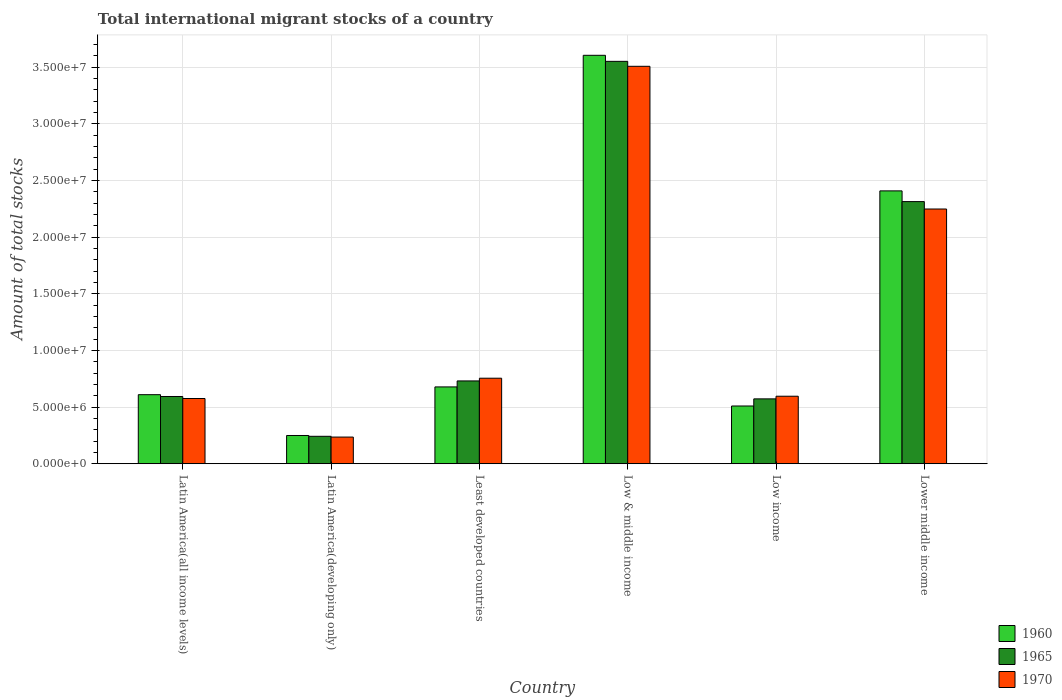How many different coloured bars are there?
Your response must be concise. 3. What is the label of the 3rd group of bars from the left?
Make the answer very short. Least developed countries. What is the amount of total stocks in in 1960 in Low & middle income?
Ensure brevity in your answer.  3.61e+07. Across all countries, what is the maximum amount of total stocks in in 1970?
Make the answer very short. 3.51e+07. Across all countries, what is the minimum amount of total stocks in in 1965?
Give a very brief answer. 2.42e+06. In which country was the amount of total stocks in in 1965 minimum?
Give a very brief answer. Latin America(developing only). What is the total amount of total stocks in in 1970 in the graph?
Your answer should be very brief. 7.92e+07. What is the difference between the amount of total stocks in in 1965 in Latin America(all income levels) and that in Latin America(developing only)?
Make the answer very short. 3.51e+06. What is the difference between the amount of total stocks in in 1970 in Low income and the amount of total stocks in in 1965 in Least developed countries?
Give a very brief answer. -1.35e+06. What is the average amount of total stocks in in 1970 per country?
Your answer should be compact. 1.32e+07. What is the difference between the amount of total stocks in of/in 1965 and amount of total stocks in of/in 1960 in Low income?
Provide a succinct answer. 6.30e+05. What is the ratio of the amount of total stocks in in 1960 in Latin America(all income levels) to that in Lower middle income?
Offer a very short reply. 0.25. Is the amount of total stocks in in 1960 in Low & middle income less than that in Lower middle income?
Offer a terse response. No. What is the difference between the highest and the second highest amount of total stocks in in 1970?
Give a very brief answer. 1.49e+07. What is the difference between the highest and the lowest amount of total stocks in in 1965?
Make the answer very short. 3.31e+07. Is the sum of the amount of total stocks in in 1965 in Low income and Lower middle income greater than the maximum amount of total stocks in in 1970 across all countries?
Ensure brevity in your answer.  No. What does the 1st bar from the left in Low income represents?
Provide a short and direct response. 1960. How many countries are there in the graph?
Your answer should be very brief. 6. What is the difference between two consecutive major ticks on the Y-axis?
Provide a short and direct response. 5.00e+06. Are the values on the major ticks of Y-axis written in scientific E-notation?
Make the answer very short. Yes. Does the graph contain grids?
Offer a very short reply. Yes. What is the title of the graph?
Ensure brevity in your answer.  Total international migrant stocks of a country. Does "1974" appear as one of the legend labels in the graph?
Your response must be concise. No. What is the label or title of the X-axis?
Your answer should be very brief. Country. What is the label or title of the Y-axis?
Offer a terse response. Amount of total stocks. What is the Amount of total stocks in 1960 in Latin America(all income levels)?
Give a very brief answer. 6.10e+06. What is the Amount of total stocks in 1965 in Latin America(all income levels)?
Give a very brief answer. 5.94e+06. What is the Amount of total stocks of 1970 in Latin America(all income levels)?
Provide a short and direct response. 5.76e+06. What is the Amount of total stocks in 1960 in Latin America(developing only)?
Your answer should be very brief. 2.49e+06. What is the Amount of total stocks of 1965 in Latin America(developing only)?
Keep it short and to the point. 2.42e+06. What is the Amount of total stocks of 1970 in Latin America(developing only)?
Offer a very short reply. 2.35e+06. What is the Amount of total stocks in 1960 in Least developed countries?
Make the answer very short. 6.78e+06. What is the Amount of total stocks in 1965 in Least developed countries?
Give a very brief answer. 7.31e+06. What is the Amount of total stocks in 1970 in Least developed countries?
Provide a succinct answer. 7.55e+06. What is the Amount of total stocks in 1960 in Low & middle income?
Your answer should be very brief. 3.61e+07. What is the Amount of total stocks of 1965 in Low & middle income?
Provide a short and direct response. 3.55e+07. What is the Amount of total stocks of 1970 in Low & middle income?
Ensure brevity in your answer.  3.51e+07. What is the Amount of total stocks in 1960 in Low income?
Provide a short and direct response. 5.10e+06. What is the Amount of total stocks of 1965 in Low income?
Your response must be concise. 5.73e+06. What is the Amount of total stocks in 1970 in Low income?
Your answer should be compact. 5.96e+06. What is the Amount of total stocks in 1960 in Lower middle income?
Offer a very short reply. 2.41e+07. What is the Amount of total stocks in 1965 in Lower middle income?
Your answer should be compact. 2.31e+07. What is the Amount of total stocks in 1970 in Lower middle income?
Provide a short and direct response. 2.25e+07. Across all countries, what is the maximum Amount of total stocks of 1960?
Offer a very short reply. 3.61e+07. Across all countries, what is the maximum Amount of total stocks of 1965?
Provide a succinct answer. 3.55e+07. Across all countries, what is the maximum Amount of total stocks of 1970?
Keep it short and to the point. 3.51e+07. Across all countries, what is the minimum Amount of total stocks in 1960?
Give a very brief answer. 2.49e+06. Across all countries, what is the minimum Amount of total stocks of 1965?
Make the answer very short. 2.42e+06. Across all countries, what is the minimum Amount of total stocks in 1970?
Your response must be concise. 2.35e+06. What is the total Amount of total stocks of 1960 in the graph?
Your response must be concise. 8.06e+07. What is the total Amount of total stocks in 1965 in the graph?
Make the answer very short. 8.01e+07. What is the total Amount of total stocks in 1970 in the graph?
Provide a short and direct response. 7.92e+07. What is the difference between the Amount of total stocks of 1960 in Latin America(all income levels) and that in Latin America(developing only)?
Offer a terse response. 3.60e+06. What is the difference between the Amount of total stocks of 1965 in Latin America(all income levels) and that in Latin America(developing only)?
Provide a short and direct response. 3.51e+06. What is the difference between the Amount of total stocks in 1970 in Latin America(all income levels) and that in Latin America(developing only)?
Offer a terse response. 3.41e+06. What is the difference between the Amount of total stocks of 1960 in Latin America(all income levels) and that in Least developed countries?
Make the answer very short. -6.86e+05. What is the difference between the Amount of total stocks of 1965 in Latin America(all income levels) and that in Least developed countries?
Provide a short and direct response. -1.37e+06. What is the difference between the Amount of total stocks of 1970 in Latin America(all income levels) and that in Least developed countries?
Offer a very short reply. -1.79e+06. What is the difference between the Amount of total stocks in 1960 in Latin America(all income levels) and that in Low & middle income?
Your answer should be very brief. -3.00e+07. What is the difference between the Amount of total stocks of 1965 in Latin America(all income levels) and that in Low & middle income?
Your response must be concise. -2.96e+07. What is the difference between the Amount of total stocks in 1970 in Latin America(all income levels) and that in Low & middle income?
Make the answer very short. -2.93e+07. What is the difference between the Amount of total stocks of 1960 in Latin America(all income levels) and that in Low income?
Offer a terse response. 9.99e+05. What is the difference between the Amount of total stocks of 1965 in Latin America(all income levels) and that in Low income?
Offer a terse response. 2.09e+05. What is the difference between the Amount of total stocks of 1970 in Latin America(all income levels) and that in Low income?
Offer a terse response. -2.01e+05. What is the difference between the Amount of total stocks of 1960 in Latin America(all income levels) and that in Lower middle income?
Provide a short and direct response. -1.80e+07. What is the difference between the Amount of total stocks of 1965 in Latin America(all income levels) and that in Lower middle income?
Provide a short and direct response. -1.72e+07. What is the difference between the Amount of total stocks of 1970 in Latin America(all income levels) and that in Lower middle income?
Your answer should be very brief. -1.67e+07. What is the difference between the Amount of total stocks of 1960 in Latin America(developing only) and that in Least developed countries?
Keep it short and to the point. -4.29e+06. What is the difference between the Amount of total stocks of 1965 in Latin America(developing only) and that in Least developed countries?
Provide a short and direct response. -4.89e+06. What is the difference between the Amount of total stocks of 1970 in Latin America(developing only) and that in Least developed countries?
Give a very brief answer. -5.20e+06. What is the difference between the Amount of total stocks of 1960 in Latin America(developing only) and that in Low & middle income?
Your response must be concise. -3.36e+07. What is the difference between the Amount of total stocks in 1965 in Latin America(developing only) and that in Low & middle income?
Your answer should be very brief. -3.31e+07. What is the difference between the Amount of total stocks in 1970 in Latin America(developing only) and that in Low & middle income?
Provide a short and direct response. -3.27e+07. What is the difference between the Amount of total stocks in 1960 in Latin America(developing only) and that in Low income?
Ensure brevity in your answer.  -2.60e+06. What is the difference between the Amount of total stocks in 1965 in Latin America(developing only) and that in Low income?
Provide a succinct answer. -3.31e+06. What is the difference between the Amount of total stocks of 1970 in Latin America(developing only) and that in Low income?
Offer a very short reply. -3.61e+06. What is the difference between the Amount of total stocks in 1960 in Latin America(developing only) and that in Lower middle income?
Keep it short and to the point. -2.16e+07. What is the difference between the Amount of total stocks in 1965 in Latin America(developing only) and that in Lower middle income?
Your answer should be very brief. -2.07e+07. What is the difference between the Amount of total stocks of 1970 in Latin America(developing only) and that in Lower middle income?
Provide a succinct answer. -2.01e+07. What is the difference between the Amount of total stocks of 1960 in Least developed countries and that in Low & middle income?
Offer a terse response. -2.93e+07. What is the difference between the Amount of total stocks in 1965 in Least developed countries and that in Low & middle income?
Provide a succinct answer. -2.82e+07. What is the difference between the Amount of total stocks in 1970 in Least developed countries and that in Low & middle income?
Offer a very short reply. -2.75e+07. What is the difference between the Amount of total stocks of 1960 in Least developed countries and that in Low income?
Your response must be concise. 1.69e+06. What is the difference between the Amount of total stocks of 1965 in Least developed countries and that in Low income?
Offer a very short reply. 1.58e+06. What is the difference between the Amount of total stocks of 1970 in Least developed countries and that in Low income?
Provide a short and direct response. 1.59e+06. What is the difference between the Amount of total stocks of 1960 in Least developed countries and that in Lower middle income?
Offer a very short reply. -1.73e+07. What is the difference between the Amount of total stocks in 1965 in Least developed countries and that in Lower middle income?
Offer a very short reply. -1.58e+07. What is the difference between the Amount of total stocks of 1970 in Least developed countries and that in Lower middle income?
Provide a short and direct response. -1.49e+07. What is the difference between the Amount of total stocks of 1960 in Low & middle income and that in Low income?
Offer a terse response. 3.10e+07. What is the difference between the Amount of total stocks of 1965 in Low & middle income and that in Low income?
Make the answer very short. 2.98e+07. What is the difference between the Amount of total stocks in 1970 in Low & middle income and that in Low income?
Your answer should be very brief. 2.91e+07. What is the difference between the Amount of total stocks in 1960 in Low & middle income and that in Lower middle income?
Make the answer very short. 1.20e+07. What is the difference between the Amount of total stocks of 1965 in Low & middle income and that in Lower middle income?
Give a very brief answer. 1.24e+07. What is the difference between the Amount of total stocks of 1970 in Low & middle income and that in Lower middle income?
Provide a succinct answer. 1.26e+07. What is the difference between the Amount of total stocks in 1960 in Low income and that in Lower middle income?
Provide a succinct answer. -1.90e+07. What is the difference between the Amount of total stocks of 1965 in Low income and that in Lower middle income?
Your response must be concise. -1.74e+07. What is the difference between the Amount of total stocks of 1970 in Low income and that in Lower middle income?
Offer a terse response. -1.65e+07. What is the difference between the Amount of total stocks of 1960 in Latin America(all income levels) and the Amount of total stocks of 1965 in Latin America(developing only)?
Provide a short and direct response. 3.67e+06. What is the difference between the Amount of total stocks of 1960 in Latin America(all income levels) and the Amount of total stocks of 1970 in Latin America(developing only)?
Ensure brevity in your answer.  3.74e+06. What is the difference between the Amount of total stocks in 1965 in Latin America(all income levels) and the Amount of total stocks in 1970 in Latin America(developing only)?
Ensure brevity in your answer.  3.58e+06. What is the difference between the Amount of total stocks of 1960 in Latin America(all income levels) and the Amount of total stocks of 1965 in Least developed countries?
Your response must be concise. -1.21e+06. What is the difference between the Amount of total stocks in 1960 in Latin America(all income levels) and the Amount of total stocks in 1970 in Least developed countries?
Give a very brief answer. -1.45e+06. What is the difference between the Amount of total stocks in 1965 in Latin America(all income levels) and the Amount of total stocks in 1970 in Least developed countries?
Make the answer very short. -1.61e+06. What is the difference between the Amount of total stocks in 1960 in Latin America(all income levels) and the Amount of total stocks in 1965 in Low & middle income?
Provide a short and direct response. -2.94e+07. What is the difference between the Amount of total stocks in 1960 in Latin America(all income levels) and the Amount of total stocks in 1970 in Low & middle income?
Your response must be concise. -2.90e+07. What is the difference between the Amount of total stocks in 1965 in Latin America(all income levels) and the Amount of total stocks in 1970 in Low & middle income?
Keep it short and to the point. -2.92e+07. What is the difference between the Amount of total stocks in 1960 in Latin America(all income levels) and the Amount of total stocks in 1965 in Low income?
Your response must be concise. 3.69e+05. What is the difference between the Amount of total stocks of 1960 in Latin America(all income levels) and the Amount of total stocks of 1970 in Low income?
Your answer should be compact. 1.36e+05. What is the difference between the Amount of total stocks of 1965 in Latin America(all income levels) and the Amount of total stocks of 1970 in Low income?
Your response must be concise. -2.38e+04. What is the difference between the Amount of total stocks in 1960 in Latin America(all income levels) and the Amount of total stocks in 1965 in Lower middle income?
Your answer should be very brief. -1.70e+07. What is the difference between the Amount of total stocks of 1960 in Latin America(all income levels) and the Amount of total stocks of 1970 in Lower middle income?
Provide a succinct answer. -1.64e+07. What is the difference between the Amount of total stocks in 1965 in Latin America(all income levels) and the Amount of total stocks in 1970 in Lower middle income?
Your answer should be compact. -1.66e+07. What is the difference between the Amount of total stocks in 1960 in Latin America(developing only) and the Amount of total stocks in 1965 in Least developed countries?
Offer a terse response. -4.82e+06. What is the difference between the Amount of total stocks of 1960 in Latin America(developing only) and the Amount of total stocks of 1970 in Least developed countries?
Give a very brief answer. -5.06e+06. What is the difference between the Amount of total stocks in 1965 in Latin America(developing only) and the Amount of total stocks in 1970 in Least developed countries?
Your response must be concise. -5.13e+06. What is the difference between the Amount of total stocks of 1960 in Latin America(developing only) and the Amount of total stocks of 1965 in Low & middle income?
Make the answer very short. -3.30e+07. What is the difference between the Amount of total stocks of 1960 in Latin America(developing only) and the Amount of total stocks of 1970 in Low & middle income?
Ensure brevity in your answer.  -3.26e+07. What is the difference between the Amount of total stocks in 1965 in Latin America(developing only) and the Amount of total stocks in 1970 in Low & middle income?
Your response must be concise. -3.27e+07. What is the difference between the Amount of total stocks in 1960 in Latin America(developing only) and the Amount of total stocks in 1965 in Low income?
Keep it short and to the point. -3.23e+06. What is the difference between the Amount of total stocks of 1960 in Latin America(developing only) and the Amount of total stocks of 1970 in Low income?
Make the answer very short. -3.47e+06. What is the difference between the Amount of total stocks in 1965 in Latin America(developing only) and the Amount of total stocks in 1970 in Low income?
Keep it short and to the point. -3.54e+06. What is the difference between the Amount of total stocks of 1960 in Latin America(developing only) and the Amount of total stocks of 1965 in Lower middle income?
Offer a very short reply. -2.07e+07. What is the difference between the Amount of total stocks in 1960 in Latin America(developing only) and the Amount of total stocks in 1970 in Lower middle income?
Provide a short and direct response. -2.00e+07. What is the difference between the Amount of total stocks in 1965 in Latin America(developing only) and the Amount of total stocks in 1970 in Lower middle income?
Provide a succinct answer. -2.01e+07. What is the difference between the Amount of total stocks of 1960 in Least developed countries and the Amount of total stocks of 1965 in Low & middle income?
Give a very brief answer. -2.87e+07. What is the difference between the Amount of total stocks in 1960 in Least developed countries and the Amount of total stocks in 1970 in Low & middle income?
Provide a short and direct response. -2.83e+07. What is the difference between the Amount of total stocks in 1965 in Least developed countries and the Amount of total stocks in 1970 in Low & middle income?
Your response must be concise. -2.78e+07. What is the difference between the Amount of total stocks in 1960 in Least developed countries and the Amount of total stocks in 1965 in Low income?
Offer a terse response. 1.06e+06. What is the difference between the Amount of total stocks of 1960 in Least developed countries and the Amount of total stocks of 1970 in Low income?
Provide a short and direct response. 8.22e+05. What is the difference between the Amount of total stocks of 1965 in Least developed countries and the Amount of total stocks of 1970 in Low income?
Make the answer very short. 1.35e+06. What is the difference between the Amount of total stocks of 1960 in Least developed countries and the Amount of total stocks of 1965 in Lower middle income?
Give a very brief answer. -1.64e+07. What is the difference between the Amount of total stocks in 1960 in Least developed countries and the Amount of total stocks in 1970 in Lower middle income?
Keep it short and to the point. -1.57e+07. What is the difference between the Amount of total stocks in 1965 in Least developed countries and the Amount of total stocks in 1970 in Lower middle income?
Your response must be concise. -1.52e+07. What is the difference between the Amount of total stocks of 1960 in Low & middle income and the Amount of total stocks of 1965 in Low income?
Give a very brief answer. 3.03e+07. What is the difference between the Amount of total stocks in 1960 in Low & middle income and the Amount of total stocks in 1970 in Low income?
Give a very brief answer. 3.01e+07. What is the difference between the Amount of total stocks in 1965 in Low & middle income and the Amount of total stocks in 1970 in Low income?
Ensure brevity in your answer.  2.96e+07. What is the difference between the Amount of total stocks of 1960 in Low & middle income and the Amount of total stocks of 1965 in Lower middle income?
Offer a terse response. 1.29e+07. What is the difference between the Amount of total stocks of 1960 in Low & middle income and the Amount of total stocks of 1970 in Lower middle income?
Give a very brief answer. 1.36e+07. What is the difference between the Amount of total stocks in 1965 in Low & middle income and the Amount of total stocks in 1970 in Lower middle income?
Your answer should be compact. 1.30e+07. What is the difference between the Amount of total stocks in 1960 in Low income and the Amount of total stocks in 1965 in Lower middle income?
Your response must be concise. -1.80e+07. What is the difference between the Amount of total stocks in 1960 in Low income and the Amount of total stocks in 1970 in Lower middle income?
Ensure brevity in your answer.  -1.74e+07. What is the difference between the Amount of total stocks in 1965 in Low income and the Amount of total stocks in 1970 in Lower middle income?
Your answer should be very brief. -1.68e+07. What is the average Amount of total stocks in 1960 per country?
Provide a short and direct response. 1.34e+07. What is the average Amount of total stocks of 1965 per country?
Make the answer very short. 1.33e+07. What is the average Amount of total stocks of 1970 per country?
Offer a terse response. 1.32e+07. What is the difference between the Amount of total stocks of 1960 and Amount of total stocks of 1965 in Latin America(all income levels)?
Provide a short and direct response. 1.60e+05. What is the difference between the Amount of total stocks in 1960 and Amount of total stocks in 1970 in Latin America(all income levels)?
Your response must be concise. 3.37e+05. What is the difference between the Amount of total stocks of 1965 and Amount of total stocks of 1970 in Latin America(all income levels)?
Keep it short and to the point. 1.77e+05. What is the difference between the Amount of total stocks in 1960 and Amount of total stocks in 1965 in Latin America(developing only)?
Provide a short and direct response. 7.11e+04. What is the difference between the Amount of total stocks in 1960 and Amount of total stocks in 1970 in Latin America(developing only)?
Ensure brevity in your answer.  1.39e+05. What is the difference between the Amount of total stocks of 1965 and Amount of total stocks of 1970 in Latin America(developing only)?
Provide a short and direct response. 6.84e+04. What is the difference between the Amount of total stocks of 1960 and Amount of total stocks of 1965 in Least developed countries?
Your response must be concise. -5.28e+05. What is the difference between the Amount of total stocks of 1960 and Amount of total stocks of 1970 in Least developed countries?
Provide a short and direct response. -7.68e+05. What is the difference between the Amount of total stocks of 1965 and Amount of total stocks of 1970 in Least developed countries?
Your answer should be compact. -2.40e+05. What is the difference between the Amount of total stocks of 1960 and Amount of total stocks of 1965 in Low & middle income?
Your response must be concise. 5.35e+05. What is the difference between the Amount of total stocks of 1960 and Amount of total stocks of 1970 in Low & middle income?
Your answer should be compact. 9.73e+05. What is the difference between the Amount of total stocks in 1965 and Amount of total stocks in 1970 in Low & middle income?
Provide a short and direct response. 4.38e+05. What is the difference between the Amount of total stocks of 1960 and Amount of total stocks of 1965 in Low income?
Give a very brief answer. -6.30e+05. What is the difference between the Amount of total stocks of 1960 and Amount of total stocks of 1970 in Low income?
Your answer should be compact. -8.63e+05. What is the difference between the Amount of total stocks in 1965 and Amount of total stocks in 1970 in Low income?
Give a very brief answer. -2.33e+05. What is the difference between the Amount of total stocks in 1960 and Amount of total stocks in 1965 in Lower middle income?
Your answer should be very brief. 9.46e+05. What is the difference between the Amount of total stocks in 1960 and Amount of total stocks in 1970 in Lower middle income?
Your answer should be very brief. 1.60e+06. What is the difference between the Amount of total stocks in 1965 and Amount of total stocks in 1970 in Lower middle income?
Offer a terse response. 6.54e+05. What is the ratio of the Amount of total stocks in 1960 in Latin America(all income levels) to that in Latin America(developing only)?
Your answer should be very brief. 2.44. What is the ratio of the Amount of total stocks of 1965 in Latin America(all income levels) to that in Latin America(developing only)?
Your answer should be very brief. 2.45. What is the ratio of the Amount of total stocks of 1970 in Latin America(all income levels) to that in Latin America(developing only)?
Ensure brevity in your answer.  2.45. What is the ratio of the Amount of total stocks in 1960 in Latin America(all income levels) to that in Least developed countries?
Your answer should be very brief. 0.9. What is the ratio of the Amount of total stocks of 1965 in Latin America(all income levels) to that in Least developed countries?
Your answer should be very brief. 0.81. What is the ratio of the Amount of total stocks of 1970 in Latin America(all income levels) to that in Least developed countries?
Your response must be concise. 0.76. What is the ratio of the Amount of total stocks of 1960 in Latin America(all income levels) to that in Low & middle income?
Make the answer very short. 0.17. What is the ratio of the Amount of total stocks in 1965 in Latin America(all income levels) to that in Low & middle income?
Your response must be concise. 0.17. What is the ratio of the Amount of total stocks in 1970 in Latin America(all income levels) to that in Low & middle income?
Provide a short and direct response. 0.16. What is the ratio of the Amount of total stocks of 1960 in Latin America(all income levels) to that in Low income?
Your response must be concise. 1.2. What is the ratio of the Amount of total stocks in 1965 in Latin America(all income levels) to that in Low income?
Ensure brevity in your answer.  1.04. What is the ratio of the Amount of total stocks of 1970 in Latin America(all income levels) to that in Low income?
Your answer should be very brief. 0.97. What is the ratio of the Amount of total stocks in 1960 in Latin America(all income levels) to that in Lower middle income?
Provide a succinct answer. 0.25. What is the ratio of the Amount of total stocks of 1965 in Latin America(all income levels) to that in Lower middle income?
Offer a very short reply. 0.26. What is the ratio of the Amount of total stocks of 1970 in Latin America(all income levels) to that in Lower middle income?
Your answer should be compact. 0.26. What is the ratio of the Amount of total stocks of 1960 in Latin America(developing only) to that in Least developed countries?
Provide a short and direct response. 0.37. What is the ratio of the Amount of total stocks of 1965 in Latin America(developing only) to that in Least developed countries?
Give a very brief answer. 0.33. What is the ratio of the Amount of total stocks in 1970 in Latin America(developing only) to that in Least developed countries?
Offer a very short reply. 0.31. What is the ratio of the Amount of total stocks in 1960 in Latin America(developing only) to that in Low & middle income?
Provide a succinct answer. 0.07. What is the ratio of the Amount of total stocks of 1965 in Latin America(developing only) to that in Low & middle income?
Your response must be concise. 0.07. What is the ratio of the Amount of total stocks of 1970 in Latin America(developing only) to that in Low & middle income?
Offer a terse response. 0.07. What is the ratio of the Amount of total stocks of 1960 in Latin America(developing only) to that in Low income?
Your response must be concise. 0.49. What is the ratio of the Amount of total stocks of 1965 in Latin America(developing only) to that in Low income?
Keep it short and to the point. 0.42. What is the ratio of the Amount of total stocks of 1970 in Latin America(developing only) to that in Low income?
Your response must be concise. 0.39. What is the ratio of the Amount of total stocks in 1960 in Latin America(developing only) to that in Lower middle income?
Provide a short and direct response. 0.1. What is the ratio of the Amount of total stocks of 1965 in Latin America(developing only) to that in Lower middle income?
Offer a terse response. 0.1. What is the ratio of the Amount of total stocks of 1970 in Latin America(developing only) to that in Lower middle income?
Offer a terse response. 0.1. What is the ratio of the Amount of total stocks of 1960 in Least developed countries to that in Low & middle income?
Your answer should be compact. 0.19. What is the ratio of the Amount of total stocks of 1965 in Least developed countries to that in Low & middle income?
Ensure brevity in your answer.  0.21. What is the ratio of the Amount of total stocks of 1970 in Least developed countries to that in Low & middle income?
Your response must be concise. 0.22. What is the ratio of the Amount of total stocks in 1960 in Least developed countries to that in Low income?
Your answer should be very brief. 1.33. What is the ratio of the Amount of total stocks of 1965 in Least developed countries to that in Low income?
Provide a succinct answer. 1.28. What is the ratio of the Amount of total stocks in 1970 in Least developed countries to that in Low income?
Make the answer very short. 1.27. What is the ratio of the Amount of total stocks of 1960 in Least developed countries to that in Lower middle income?
Offer a very short reply. 0.28. What is the ratio of the Amount of total stocks of 1965 in Least developed countries to that in Lower middle income?
Your response must be concise. 0.32. What is the ratio of the Amount of total stocks in 1970 in Least developed countries to that in Lower middle income?
Keep it short and to the point. 0.34. What is the ratio of the Amount of total stocks of 1960 in Low & middle income to that in Low income?
Your answer should be very brief. 7.07. What is the ratio of the Amount of total stocks of 1965 in Low & middle income to that in Low income?
Your response must be concise. 6.2. What is the ratio of the Amount of total stocks of 1970 in Low & middle income to that in Low income?
Your answer should be very brief. 5.89. What is the ratio of the Amount of total stocks of 1960 in Low & middle income to that in Lower middle income?
Offer a terse response. 1.5. What is the ratio of the Amount of total stocks in 1965 in Low & middle income to that in Lower middle income?
Give a very brief answer. 1.53. What is the ratio of the Amount of total stocks in 1970 in Low & middle income to that in Lower middle income?
Provide a succinct answer. 1.56. What is the ratio of the Amount of total stocks in 1960 in Low income to that in Lower middle income?
Give a very brief answer. 0.21. What is the ratio of the Amount of total stocks of 1965 in Low income to that in Lower middle income?
Offer a terse response. 0.25. What is the ratio of the Amount of total stocks in 1970 in Low income to that in Lower middle income?
Make the answer very short. 0.27. What is the difference between the highest and the second highest Amount of total stocks of 1960?
Your response must be concise. 1.20e+07. What is the difference between the highest and the second highest Amount of total stocks of 1965?
Offer a terse response. 1.24e+07. What is the difference between the highest and the second highest Amount of total stocks of 1970?
Offer a terse response. 1.26e+07. What is the difference between the highest and the lowest Amount of total stocks in 1960?
Ensure brevity in your answer.  3.36e+07. What is the difference between the highest and the lowest Amount of total stocks in 1965?
Give a very brief answer. 3.31e+07. What is the difference between the highest and the lowest Amount of total stocks in 1970?
Make the answer very short. 3.27e+07. 